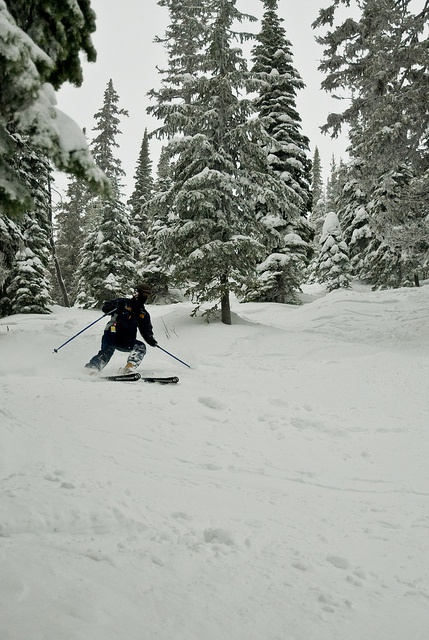Describe the objects in this image and their specific colors. I can see people in darkgray, black, gray, and purple tones and skis in darkgray, black, gray, and lightgray tones in this image. 